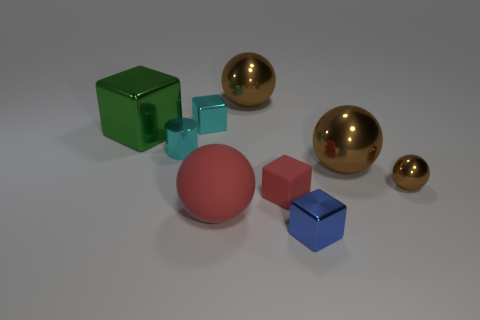Subtract all brown spheres. How many were subtracted if there are1brown spheres left? 2 Subtract all gray blocks. How many brown balls are left? 3 Add 1 small shiny balls. How many objects exist? 10 Subtract all cylinders. How many objects are left? 8 Add 9 green matte spheres. How many green matte spheres exist? 9 Subtract 1 red spheres. How many objects are left? 8 Subtract all large cubes. Subtract all small cyan things. How many objects are left? 6 Add 1 tiny red things. How many tiny red things are left? 2 